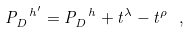<formula> <loc_0><loc_0><loc_500><loc_500>P _ { D } ^ { \ h ^ { \prime } } = P _ { D } ^ { \ h } + t ^ { \lambda } - t ^ { \rho } \ ,</formula> 